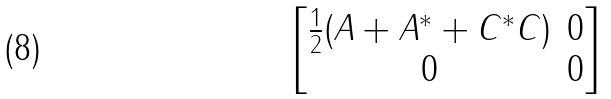Convert formula to latex. <formula><loc_0><loc_0><loc_500><loc_500>\begin{bmatrix} \frac { 1 } { 2 } ( A + A ^ { * } + C ^ { * } C ) & 0 \\ 0 & 0 \end{bmatrix}</formula> 